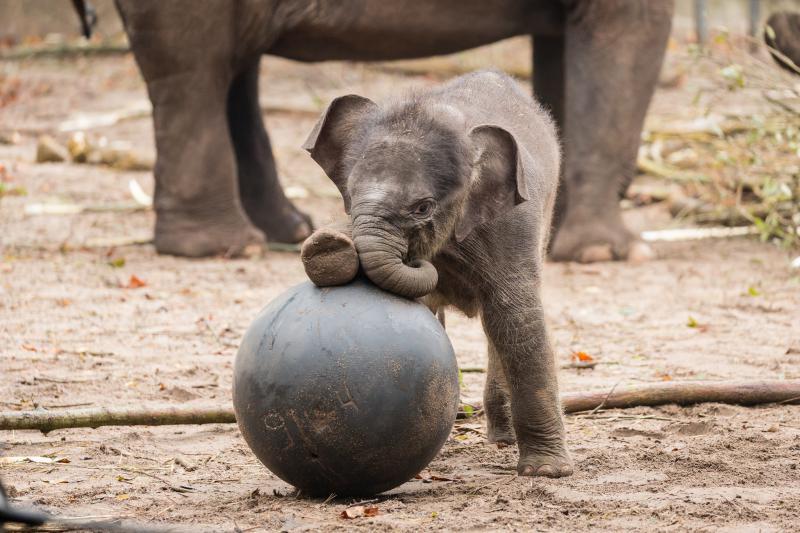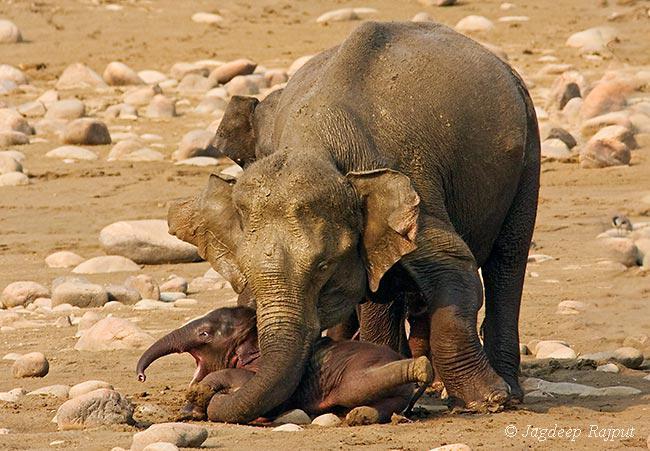The first image is the image on the left, the second image is the image on the right. Considering the images on both sides, is "One of the images shows only one elephant." valid? Answer yes or no. No. The first image is the image on the left, the second image is the image on the right. Evaluate the accuracy of this statement regarding the images: "there are two elephants in the image on the right". Is it true? Answer yes or no. Yes. 